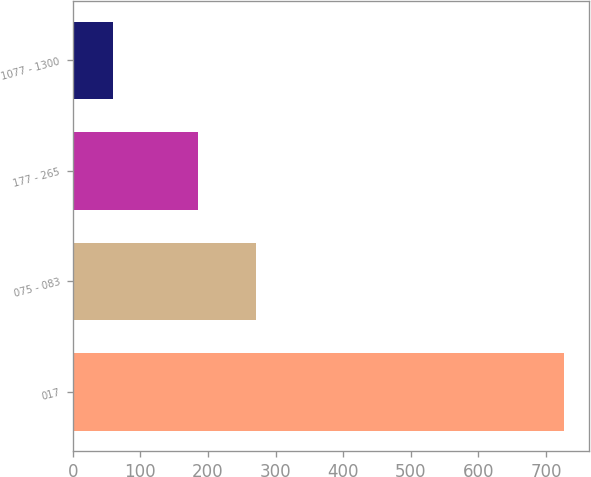<chart> <loc_0><loc_0><loc_500><loc_500><bar_chart><fcel>017<fcel>075 - 083<fcel>177 - 265<fcel>1077 - 1300<nl><fcel>727<fcel>271<fcel>185<fcel>60<nl></chart> 